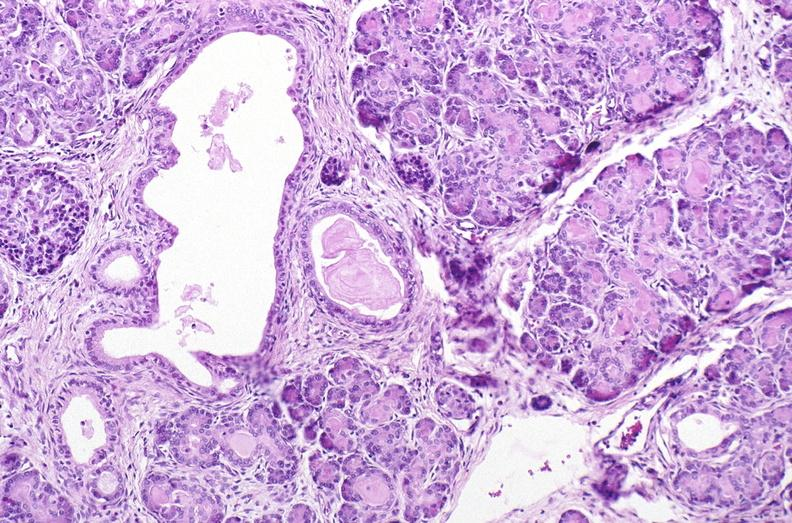s pancreas present?
Answer the question using a single word or phrase. Yes 